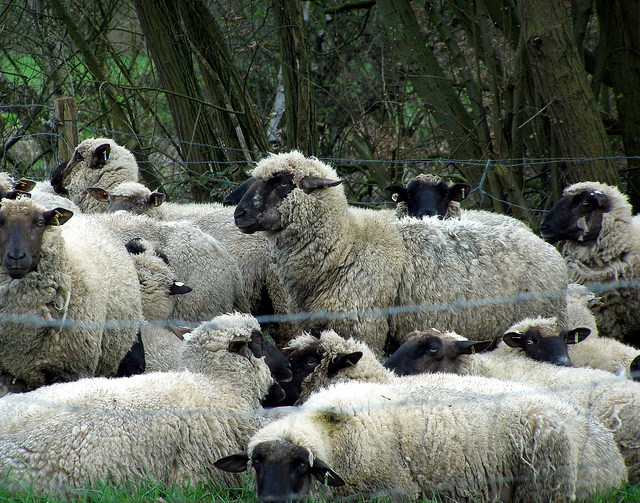Can you tell me which season this image might have been taken in? Based on the dense greenery and the condition of the sheep's woolly coats, it might be late spring to early summer. The lush vegetation suggests a time of year when plant life is thriving. Do you think the sheep are being prepared for shearing? It's possible. The sheep’s coats look thick and full, which could indicate they're ready to be sheared, especially as temperatures rise in late spring or early summer. Imagine the sheep decided to host a party, what special preparations would they make? If the sheep decided to host a party, imagine them decorating the field with garlands made from flowers they found. They might arrange their wool in fancy patterns and invite other farm animals. The event could feature a grassy feast, communal bleating songs, and playful frolicking around the field. Perhaps some of the braver sheep would attempt daring jumps over the fence to impress their friends! 